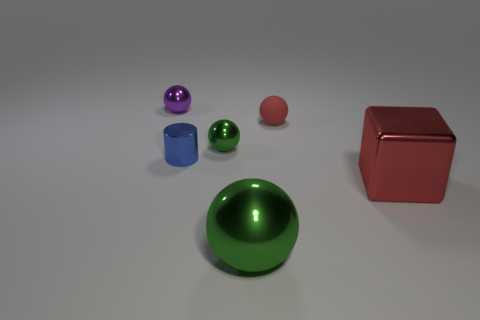Subtract all red blocks. How many green balls are left? 2 Subtract all big shiny spheres. How many spheres are left? 3 Subtract all red balls. How many balls are left? 3 Add 3 metal cubes. How many objects exist? 9 Subtract all cyan balls. Subtract all red blocks. How many balls are left? 4 Subtract all cylinders. How many objects are left? 5 Subtract all big cubes. Subtract all tiny green rubber objects. How many objects are left? 5 Add 6 large green things. How many large green things are left? 7 Add 6 large green shiny things. How many large green shiny things exist? 7 Subtract 1 red blocks. How many objects are left? 5 